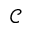Convert formula to latex. <formula><loc_0><loc_0><loc_500><loc_500>\mathcal { C }</formula> 